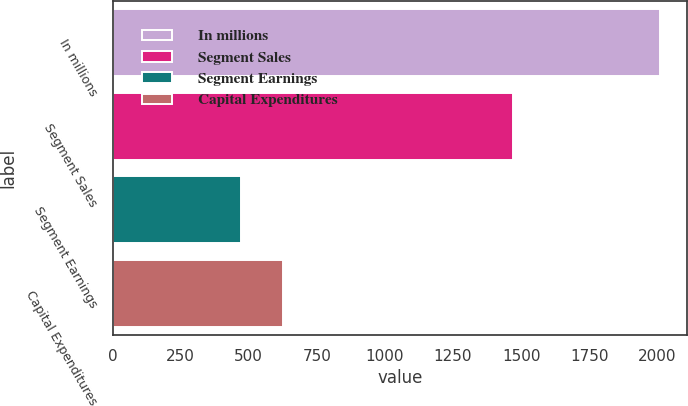<chart> <loc_0><loc_0><loc_500><loc_500><bar_chart><fcel>In millions<fcel>Segment Sales<fcel>Segment Earnings<fcel>Capital Expenditures<nl><fcel>2010<fcel>1471<fcel>472<fcel>625.8<nl></chart> 